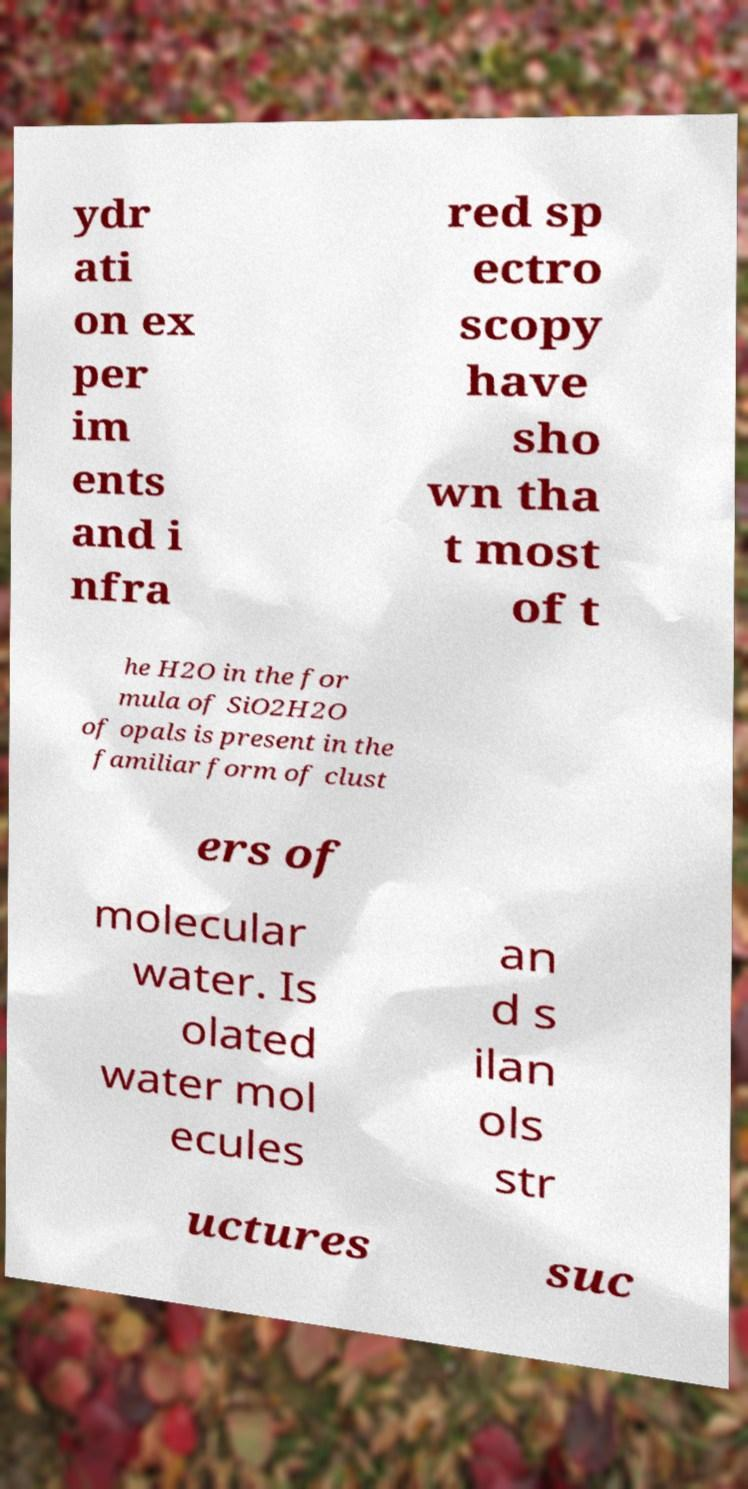There's text embedded in this image that I need extracted. Can you transcribe it verbatim? ydr ati on ex per im ents and i nfra red sp ectro scopy have sho wn tha t most of t he H2O in the for mula of SiO2H2O of opals is present in the familiar form of clust ers of molecular water. Is olated water mol ecules an d s ilan ols str uctures suc 